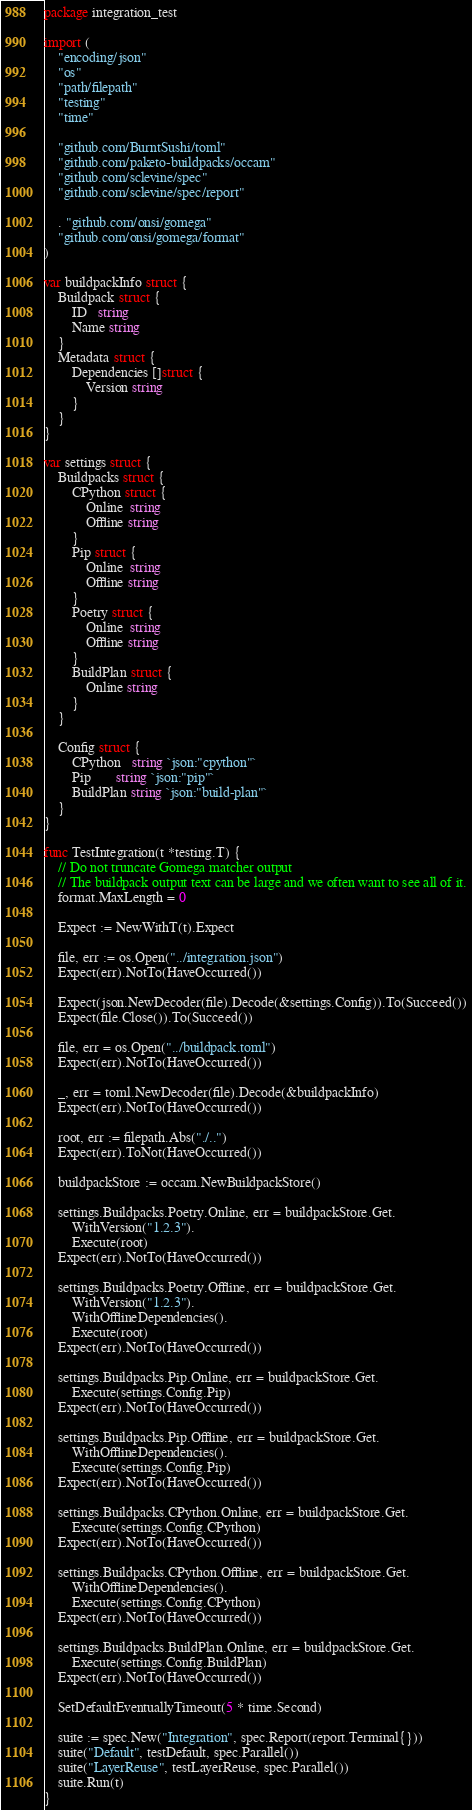Convert code to text. <code><loc_0><loc_0><loc_500><loc_500><_Go_>package integration_test

import (
	"encoding/json"
	"os"
	"path/filepath"
	"testing"
	"time"

	"github.com/BurntSushi/toml"
	"github.com/paketo-buildpacks/occam"
	"github.com/sclevine/spec"
	"github.com/sclevine/spec/report"

	. "github.com/onsi/gomega"
	"github.com/onsi/gomega/format"
)

var buildpackInfo struct {
	Buildpack struct {
		ID   string
		Name string
	}
	Metadata struct {
		Dependencies []struct {
			Version string
		}
	}
}

var settings struct {
	Buildpacks struct {
		CPython struct {
			Online  string
			Offline string
		}
		Pip struct {
			Online  string
			Offline string
		}
		Poetry struct {
			Online  string
			Offline string
		}
		BuildPlan struct {
			Online string
		}
	}

	Config struct {
		CPython   string `json:"cpython"`
		Pip       string `json:"pip"`
		BuildPlan string `json:"build-plan"`
	}
}

func TestIntegration(t *testing.T) {
	// Do not truncate Gomega matcher output
	// The buildpack output text can be large and we often want to see all of it.
	format.MaxLength = 0

	Expect := NewWithT(t).Expect

	file, err := os.Open("../integration.json")
	Expect(err).NotTo(HaveOccurred())

	Expect(json.NewDecoder(file).Decode(&settings.Config)).To(Succeed())
	Expect(file.Close()).To(Succeed())

	file, err = os.Open("../buildpack.toml")
	Expect(err).NotTo(HaveOccurred())

	_, err = toml.NewDecoder(file).Decode(&buildpackInfo)
	Expect(err).NotTo(HaveOccurred())

	root, err := filepath.Abs("./..")
	Expect(err).ToNot(HaveOccurred())

	buildpackStore := occam.NewBuildpackStore()

	settings.Buildpacks.Poetry.Online, err = buildpackStore.Get.
		WithVersion("1.2.3").
		Execute(root)
	Expect(err).NotTo(HaveOccurred())

	settings.Buildpacks.Poetry.Offline, err = buildpackStore.Get.
		WithVersion("1.2.3").
		WithOfflineDependencies().
		Execute(root)
	Expect(err).NotTo(HaveOccurred())

	settings.Buildpacks.Pip.Online, err = buildpackStore.Get.
		Execute(settings.Config.Pip)
	Expect(err).NotTo(HaveOccurred())

	settings.Buildpacks.Pip.Offline, err = buildpackStore.Get.
		WithOfflineDependencies().
		Execute(settings.Config.Pip)
	Expect(err).NotTo(HaveOccurred())

	settings.Buildpacks.CPython.Online, err = buildpackStore.Get.
		Execute(settings.Config.CPython)
	Expect(err).NotTo(HaveOccurred())

	settings.Buildpacks.CPython.Offline, err = buildpackStore.Get.
		WithOfflineDependencies().
		Execute(settings.Config.CPython)
	Expect(err).NotTo(HaveOccurred())

	settings.Buildpacks.BuildPlan.Online, err = buildpackStore.Get.
		Execute(settings.Config.BuildPlan)
	Expect(err).NotTo(HaveOccurred())

	SetDefaultEventuallyTimeout(5 * time.Second)

	suite := spec.New("Integration", spec.Report(report.Terminal{}))
	suite("Default", testDefault, spec.Parallel())
	suite("LayerReuse", testLayerReuse, spec.Parallel())
	suite.Run(t)
}
</code> 